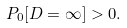Convert formula to latex. <formula><loc_0><loc_0><loc_500><loc_500>P _ { 0 } [ D = \infty ] > 0 .</formula> 